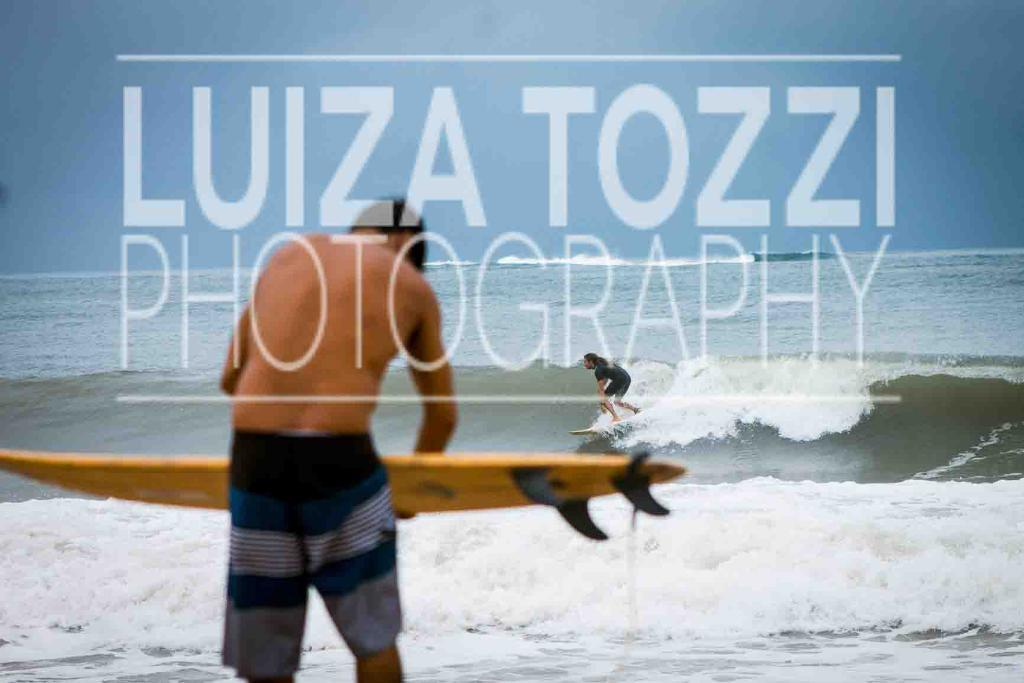Who is the main subject in the image? There is a man in the center of the image. What is the man doing in the image? The man is holding an object. What can be seen in the background of the image? The sky and water are visible in the background of the image. Are there any other people in the image besides the man? Yes, there is at least one person on the water. What is the price of the juice being sold by the man in the image? There is no juice being sold by the man in the image, and therefore no price can be determined. 